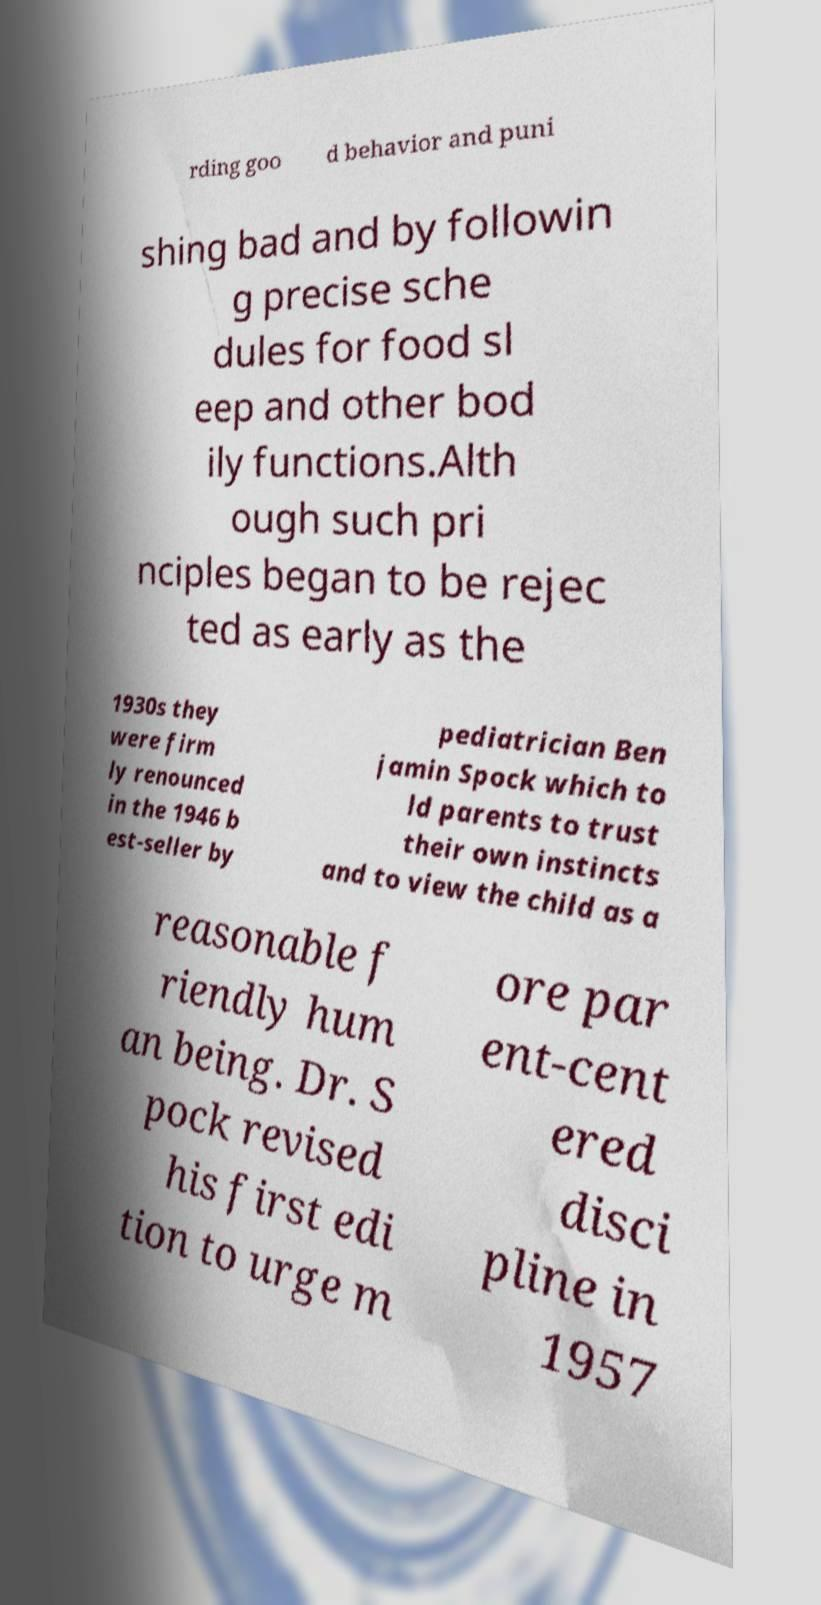Could you extract and type out the text from this image? rding goo d behavior and puni shing bad and by followin g precise sche dules for food sl eep and other bod ily functions.Alth ough such pri nciples began to be rejec ted as early as the 1930s they were firm ly renounced in the 1946 b est-seller by pediatrician Ben jamin Spock which to ld parents to trust their own instincts and to view the child as a reasonable f riendly hum an being. Dr. S pock revised his first edi tion to urge m ore par ent-cent ered disci pline in 1957 